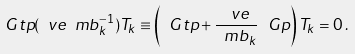<formula> <loc_0><loc_0><loc_500><loc_500>\ G t p ( \ v e \ m b _ { k } ^ { - 1 } ) T _ { k } \equiv \left ( \ G t p + \frac { \ v e } { \ m b _ { k } } \, \ G p \right ) T _ { k } = 0 \, .</formula> 